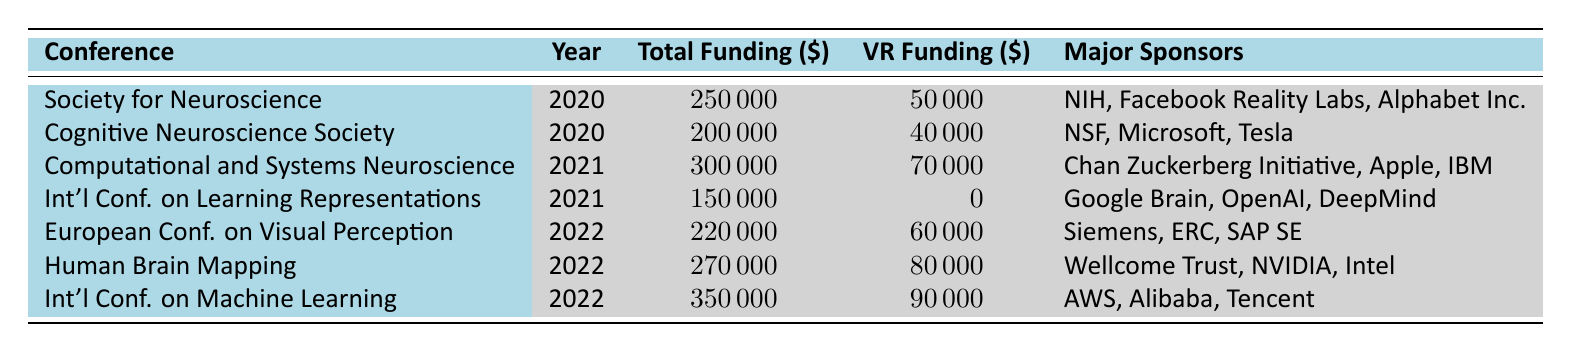What was the total funding for the Society for Neuroscience conference in 2020? The table shows the total funding for the Society for Neuroscience conference in 2020 as 250000 dollars.
Answer: 250000 How much funding was allocated specifically for VR technology in the Human Brain Mapping conference in 2022? According to the table, the funding for VR technology in the Human Brain Mapping conference in 2022 was 80000 dollars.
Answer: 80000 Which conference in 2021 received the highest total funding and what was that amount? The table indicates that the Computational and Systems Neuroscience conference received the highest total funding in 2021, which was 300000 dollars.
Answer: 300000 Did the International Conference on Learning Representations in 2021 receive any funding for VR technology? The table shows that the International Conference on Learning Representations did not receive any funding for VR technology, as the amount is listed as 0 dollars.
Answer: No What is the average total funding for the conferences that funded VR technology from 2020 to 2022? To find the average total funding for conferences that funded VR technology, we identify the relevant conferences: Society for Neuroscience (250000), Cognitive Neuroscience Society (200000), Computational and Systems Neuroscience (300000), European Conference on Visual Perception (220000), Human Brain Mapping (270000), and International Conference on Machine Learning (350000). Adding these amounts gives us 250000 + 200000 + 300000 + 220000 + 270000 + 350000 = 1590000. There are 6 conferences, so the average total funding is 1590000 / 6 = 265000.
Answer: 265000 Which major sponsor was common in the conferences that funded VR technology in 2021? Reviewing the major sponsors for the 2021 conferences (Computational and Systems Neuroscience and International Conference on Learning Representations), only the Chan Zuckerberg Initiative funded the computational conference, while the latter had Google Brain, OpenAI, and DeepMind, showing that there was no common major sponsor in 2021 for those who funded VR technology.
Answer: None 